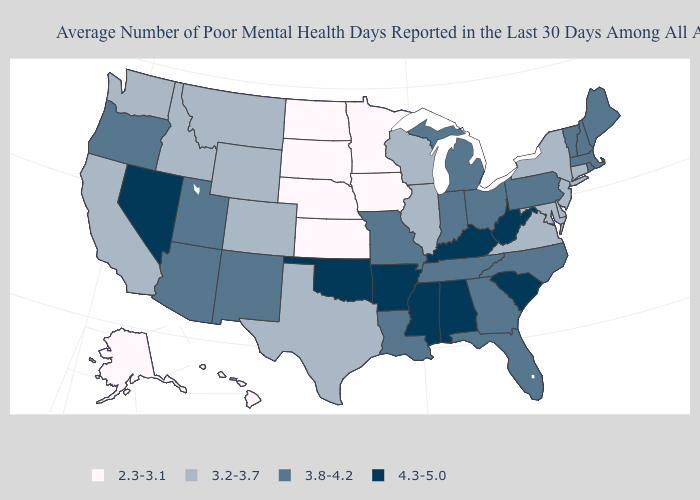Among the states that border New Mexico , does Arizona have the highest value?
Concise answer only. No. Name the states that have a value in the range 3.2-3.7?
Give a very brief answer. California, Colorado, Connecticut, Delaware, Idaho, Illinois, Maryland, Montana, New Jersey, New York, Texas, Virginia, Washington, Wisconsin, Wyoming. Does the map have missing data?
Keep it brief. No. Name the states that have a value in the range 2.3-3.1?
Answer briefly. Alaska, Hawaii, Iowa, Kansas, Minnesota, Nebraska, North Dakota, South Dakota. Is the legend a continuous bar?
Concise answer only. No. Is the legend a continuous bar?
Concise answer only. No. Name the states that have a value in the range 3.2-3.7?
Give a very brief answer. California, Colorado, Connecticut, Delaware, Idaho, Illinois, Maryland, Montana, New Jersey, New York, Texas, Virginia, Washington, Wisconsin, Wyoming. Name the states that have a value in the range 3.2-3.7?
Concise answer only. California, Colorado, Connecticut, Delaware, Idaho, Illinois, Maryland, Montana, New Jersey, New York, Texas, Virginia, Washington, Wisconsin, Wyoming. What is the value of New Mexico?
Give a very brief answer. 3.8-4.2. Name the states that have a value in the range 3.8-4.2?
Concise answer only. Arizona, Florida, Georgia, Indiana, Louisiana, Maine, Massachusetts, Michigan, Missouri, New Hampshire, New Mexico, North Carolina, Ohio, Oregon, Pennsylvania, Rhode Island, Tennessee, Utah, Vermont. Name the states that have a value in the range 3.8-4.2?
Short answer required. Arizona, Florida, Georgia, Indiana, Louisiana, Maine, Massachusetts, Michigan, Missouri, New Hampshire, New Mexico, North Carolina, Ohio, Oregon, Pennsylvania, Rhode Island, Tennessee, Utah, Vermont. Is the legend a continuous bar?
Quick response, please. No. What is the highest value in states that border Georgia?
Short answer required. 4.3-5.0. What is the value of Tennessee?
Quick response, please. 3.8-4.2. Which states have the lowest value in the MidWest?
Be succinct. Iowa, Kansas, Minnesota, Nebraska, North Dakota, South Dakota. 